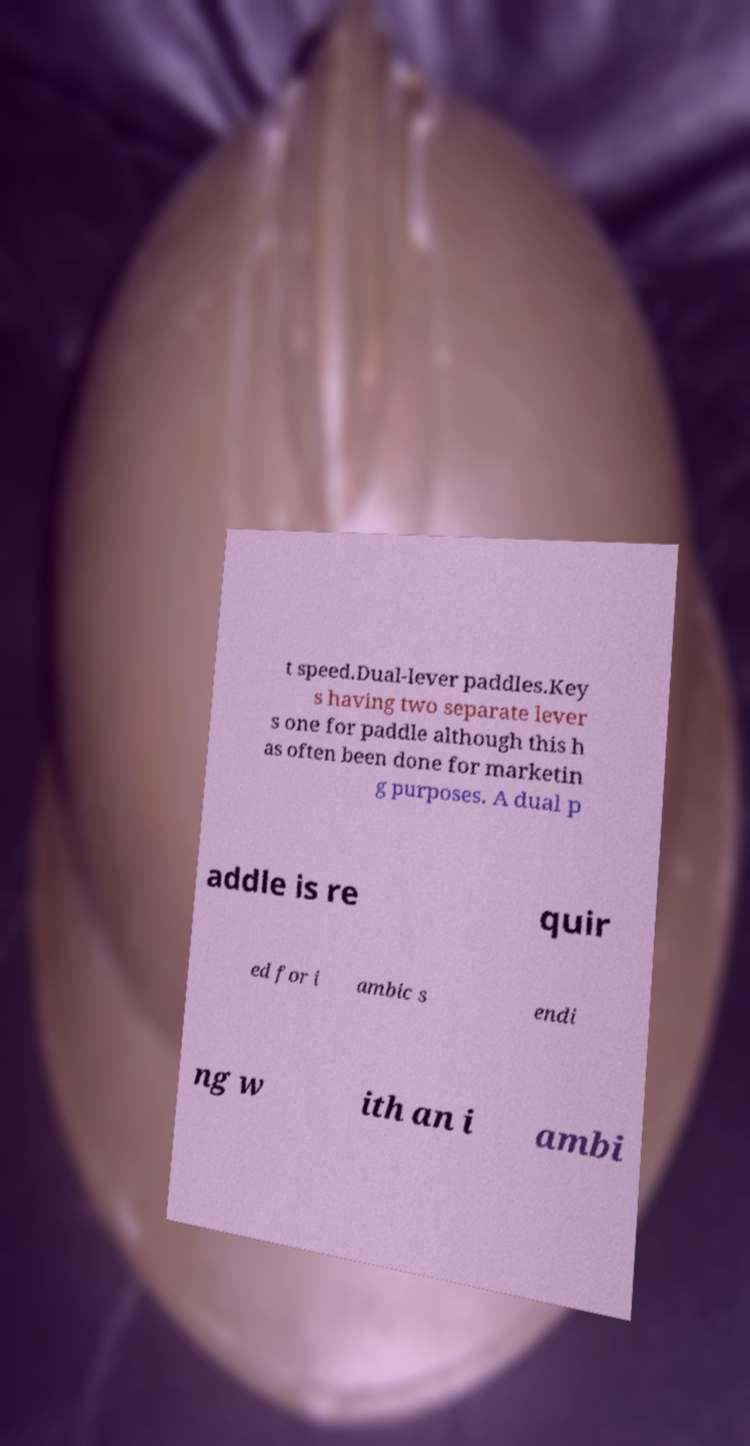Could you assist in decoding the text presented in this image and type it out clearly? t speed.Dual-lever paddles.Key s having two separate lever s one for paddle although this h as often been done for marketin g purposes. A dual p addle is re quir ed for i ambic s endi ng w ith an i ambi 